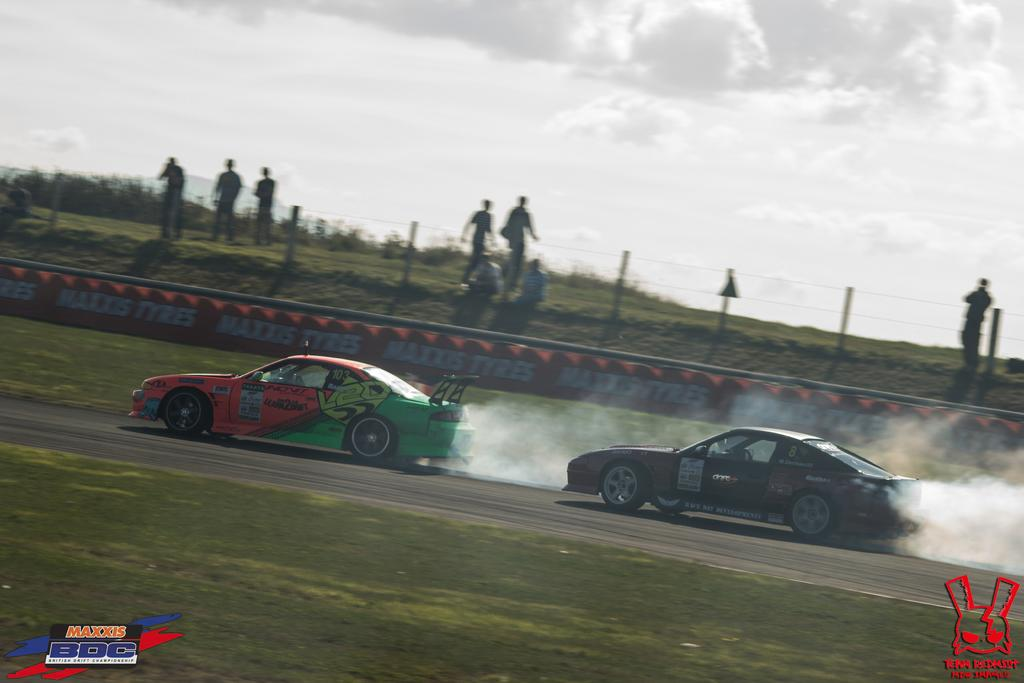How many cars can be seen in the image? There are two cars in the image. What are the cars doing in the image? The cars are moving on the road. Can you describe any emissions coming from the cars? The cars are emitting smoke. What is located behind the cars in the image? There is a fencing behind the cars. What can be seen behind the fencing? There are people behind the fencing. Can you see any veins in the cars' engines in the image? There are no visible engines in the image, so it is not possible to see any veins in them. 